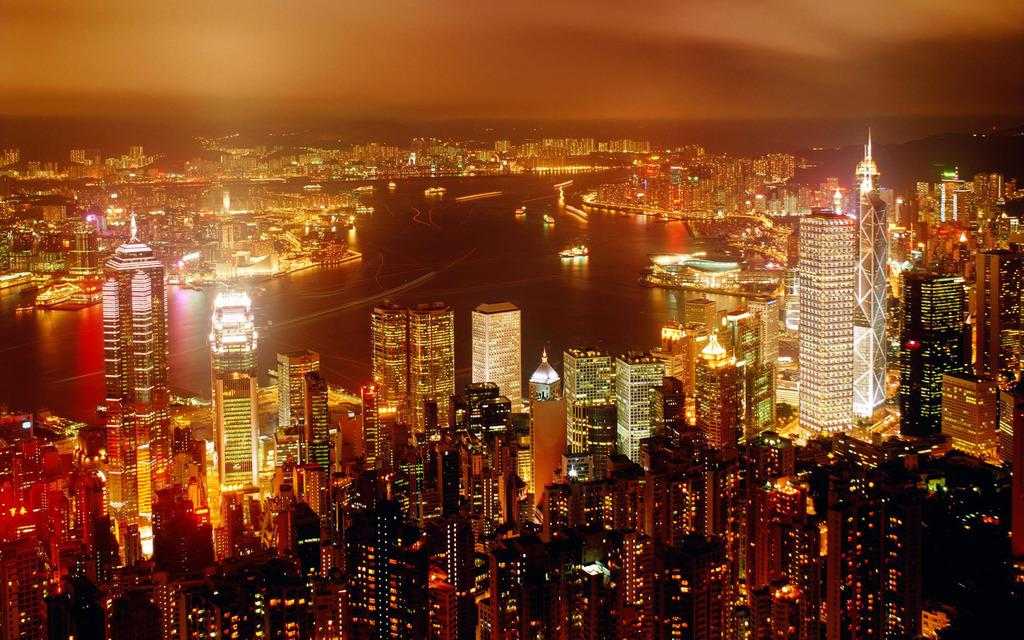What type of structures can be seen in the image? There is a group of buildings in the image. Are there any specific features of these buildings? Yes, there are towers visible in the image. What else can be seen in the image besides the buildings? There are lights visible in the image. What natural feature is present in the image? There is a large water body in the image. How would you describe the sky in the image? The sky is visible in the image and appears cloudy. What type of nerve can be seen running through the jeans in the image? There are no jeans or nerves present in the image; it features a group of buildings, towers, lights, a large water body, and a cloudy sky. 